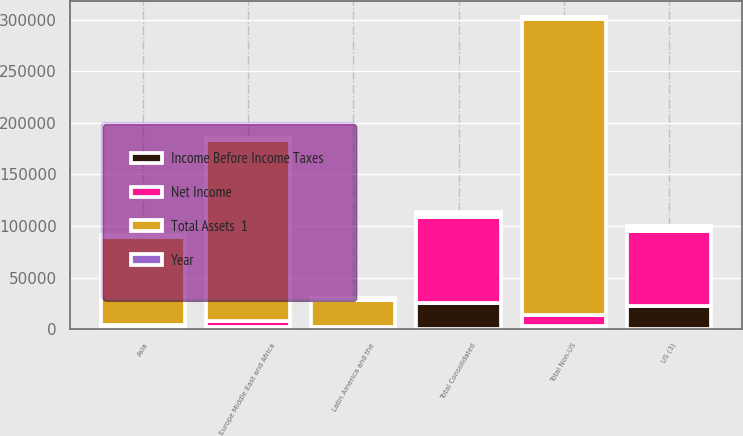Convert chart. <chart><loc_0><loc_0><loc_500><loc_500><stacked_bar_chart><ecel><fcel>US (3)<fcel>Asia<fcel>Europe Middle East and Africa<fcel>Latin America and the<fcel>Total Non-US<fcel>Total Consolidated<nl><fcel>Year<fcel>2016<fcel>2016<fcel>2016<fcel>2016<fcel>2016<fcel>2016<nl><fcel>Total Assets  1<fcel>3052<fcel>85410<fcel>174934<fcel>26680<fcel>287024<fcel>3052<nl><fcel>Net Income<fcel>72418<fcel>3365<fcel>6608<fcel>1310<fcel>11283<fcel>83701<nl><fcel>Income Before Income Taxes<fcel>22414<fcel>674<fcel>1705<fcel>360<fcel>2739<fcel>25153<nl></chart> 